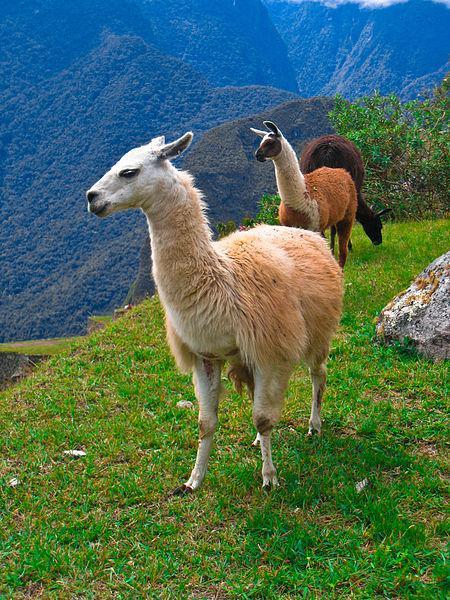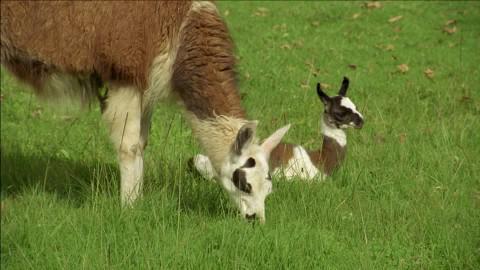The first image is the image on the left, the second image is the image on the right. Examine the images to the left and right. Is the description "A juvenile llama can be seen near an adult llama." accurate? Answer yes or no. Yes. 